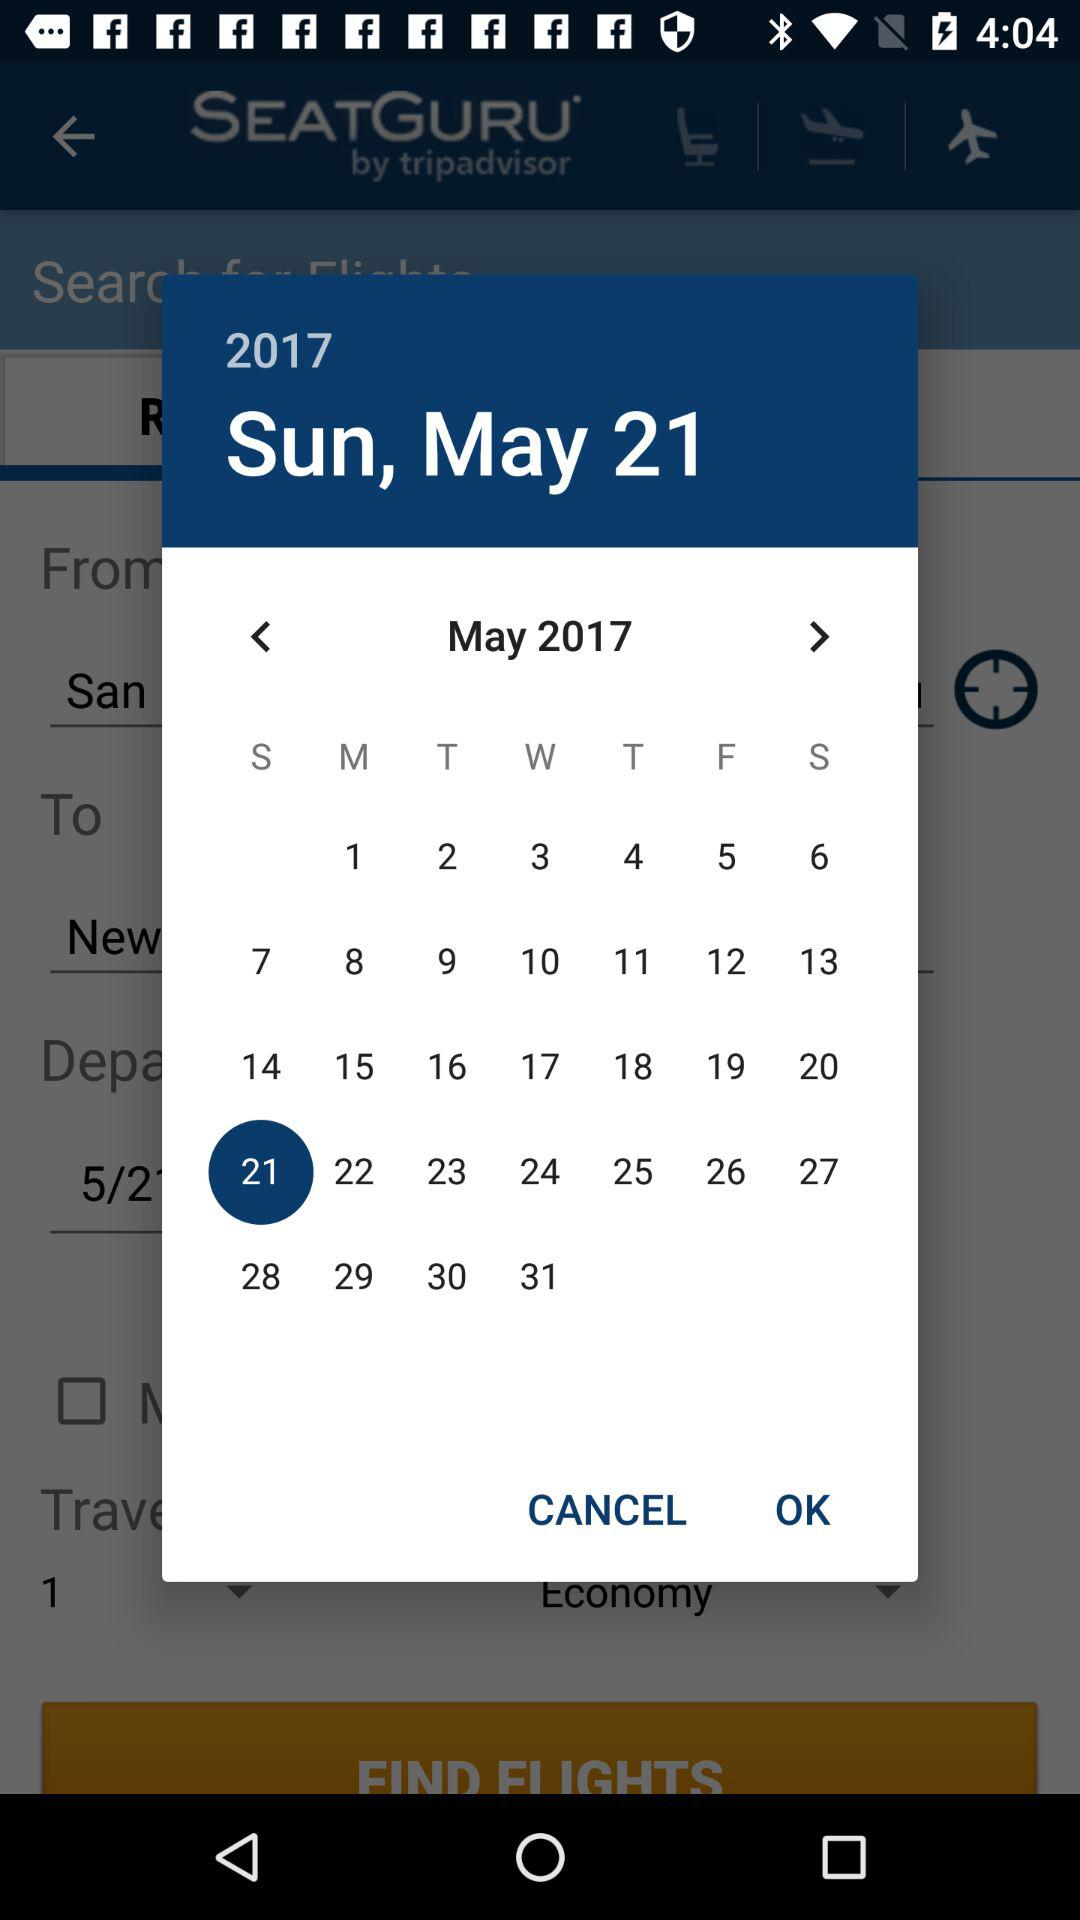What is the selected date? The selected date is Sunday, May 21, 2017. 